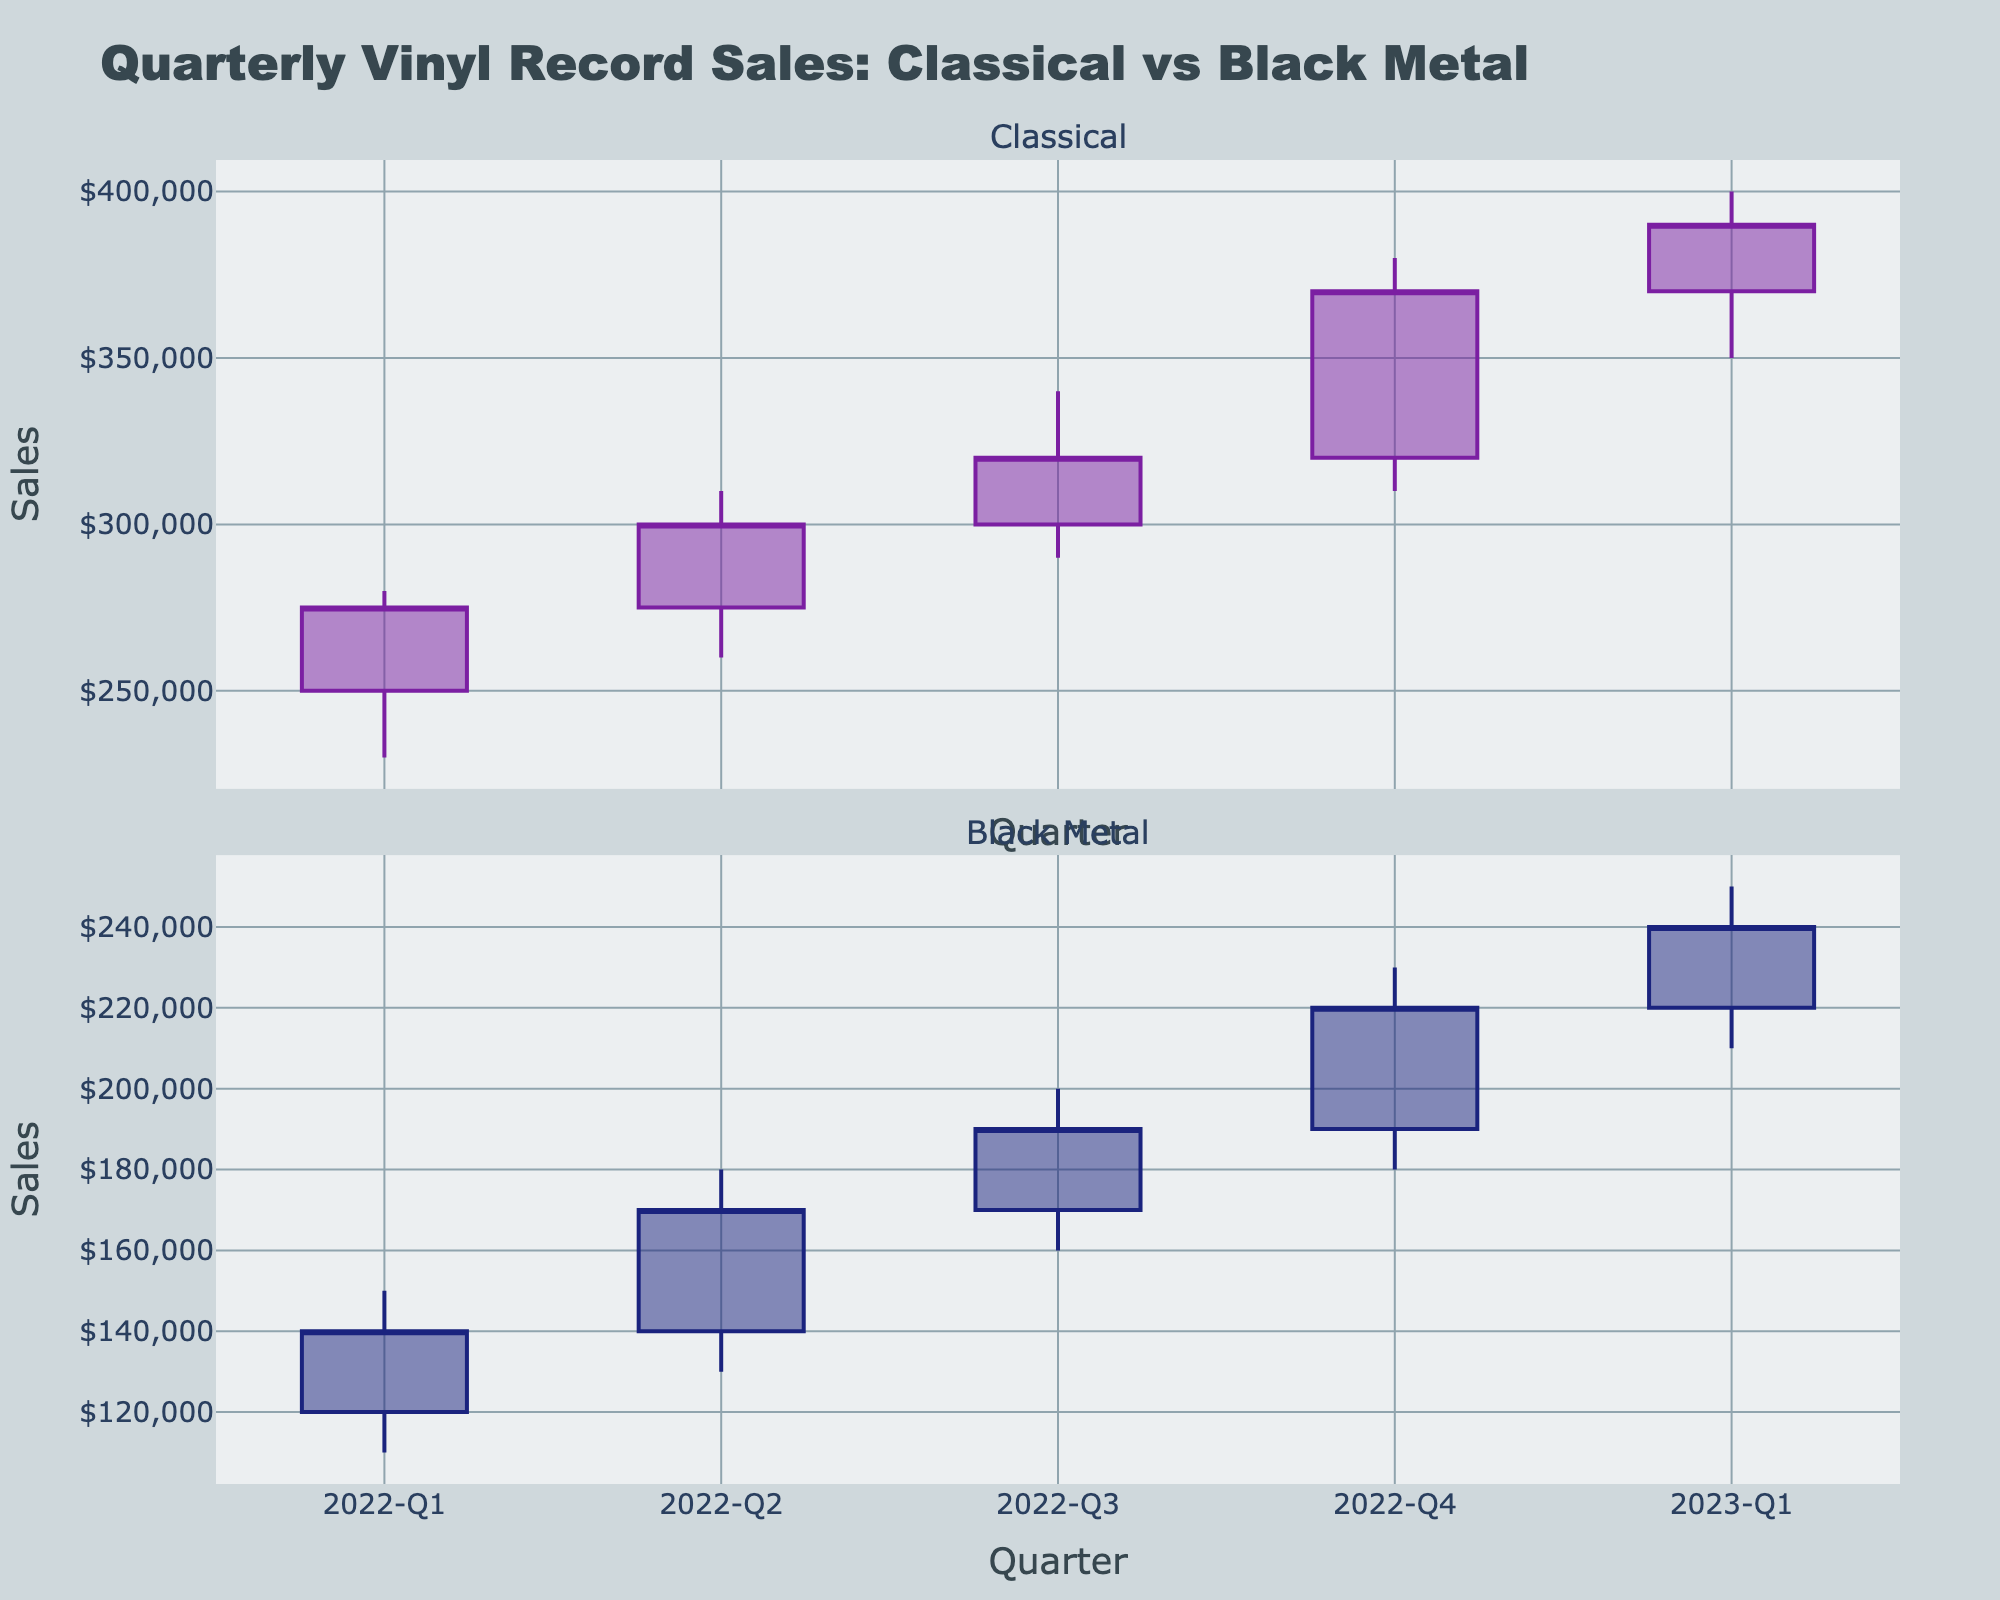What are the highest and lowest points for classical vinyl record sales in 2022-Q4? Looking at the classical vinyl record sales data for 2022-Q4, we see that the highest point is the "High" value and the lowest point is the "Low" value. The highest point is 380,000 and the lowest point is 310,000.
Answer: 380,000 (High), 310,000 (Low) What is the closing sales figure for black metal vinyl records in 2023-Q1? In 2023-Q1, the closing sales figure for black metal vinyl records is shown under the "Close" column. By checking the figure, we see the value is 240,000.
Answer: 240,000 How much did classical vinyl record sales increase from the opening to the closing in 2022-Q2? We need to find the difference between the "Close" and "Open" sales figures for classical vinyl records in 2022-Q2. The closing value is 300,000 and the opening value is 275,000. Therefore, the increase is 300,000 - 275,000 = 25,000.
Answer: 25,000 Which genre had a higher high point in 2023-Q1, and what are the respective values? To compare, we need to look at the "High" values for both genres in 2023-Q1. Classical had a high of 400,000 and Black Metal had a high of 250,000. Therefore, Classical had the higher high point.
Answer: Classical: 400,000, Black Metal: 250,000 What is the overall trend in classical vinyl record sales from 2022-Q1 to 2023-Q1? To determine the trend, we observe the change in the "Close" values for classical vinyl records from 2022-Q1 to 2023-Q1. The values rise progressively: 275,000 (2022-Q1), 300,000 (2022-Q2), 320,000 (2022-Q3), 370,000 (2022-Q4), 390,000 (2023-Q1). This indicates an overall upward trend in sales.
Answer: Upward trend Which quarter saw the highest closing value for black metal vinyl records, and what was that value? Looking at the "Close" values for black metal vinyl records across all quarters, 2022-Q4 has the highest closing value, which is 220,000.
Answer: 2022-Q4, 220,000 What is the difference between the highest and lowest sales figures for classical vinyl records in 2022-Q3? We need to subtract the "Low" value from the "High" value for classical vinyl records in 2022-Q3. The "High" value is 340,000 and the "Low" value is 290,000. So, the difference is 340,000 - 290,000 = 50,000.
Answer: 50,000 How did the sales figures for black metal vinyl records fluctuate between 2022-Q1 and 2022-Q2? Comparing the sales from 2022-Q1 to 2022-Q2, the "Close" value for 2022-Q1 is 140,000 and for 2022-Q2 it is 170,000. This indicates an increase of 170,000 - 140,000 = 30,000.
Answer: Increased by 30,000 